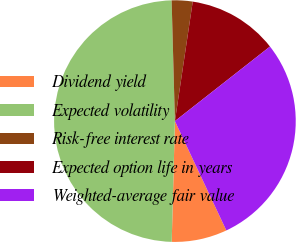Convert chart to OTSL. <chart><loc_0><loc_0><loc_500><loc_500><pie_chart><fcel>Dividend yield<fcel>Expected volatility<fcel>Risk-free interest rate<fcel>Expected option life in years<fcel>Weighted-average fair value<nl><fcel>7.42%<fcel>49.15%<fcel>2.79%<fcel>12.06%<fcel>28.59%<nl></chart> 